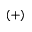<formula> <loc_0><loc_0><loc_500><loc_500>( + )</formula> 